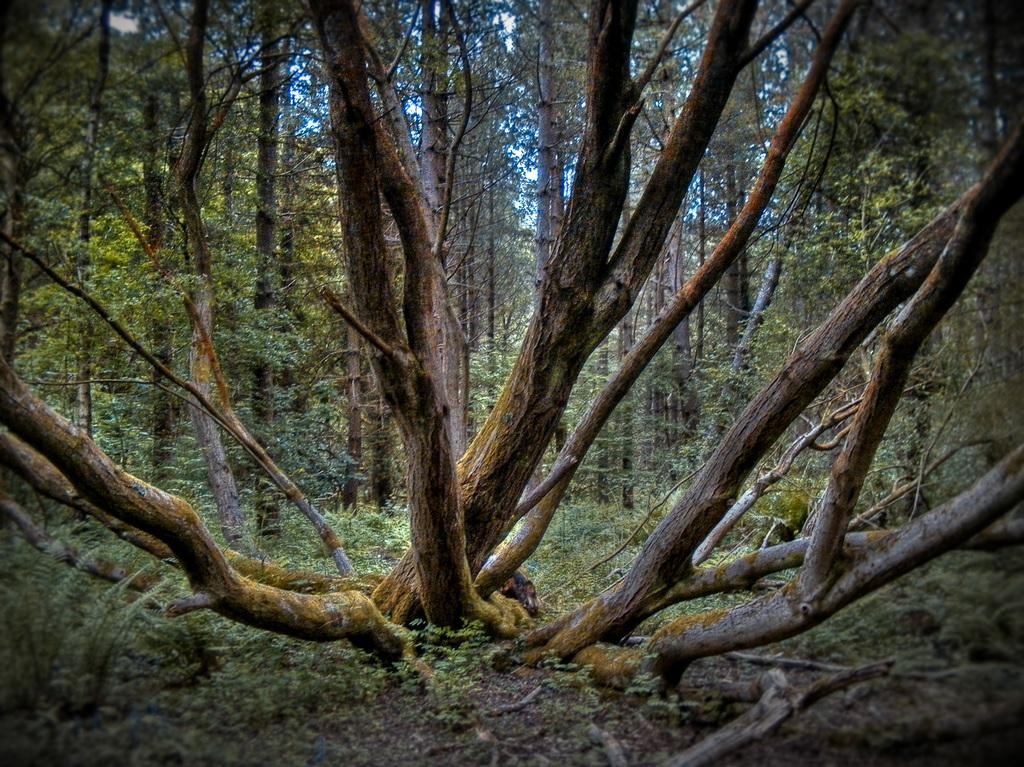What type of vegetation is visible in the image? There is grass in the image. What other natural elements can be seen in the image? There are trees in the image. What part of the natural environment is visible in the image? The sky is visible in the image. What size sack is being carried by the brother in the image? There is no brother or sack present in the image. 